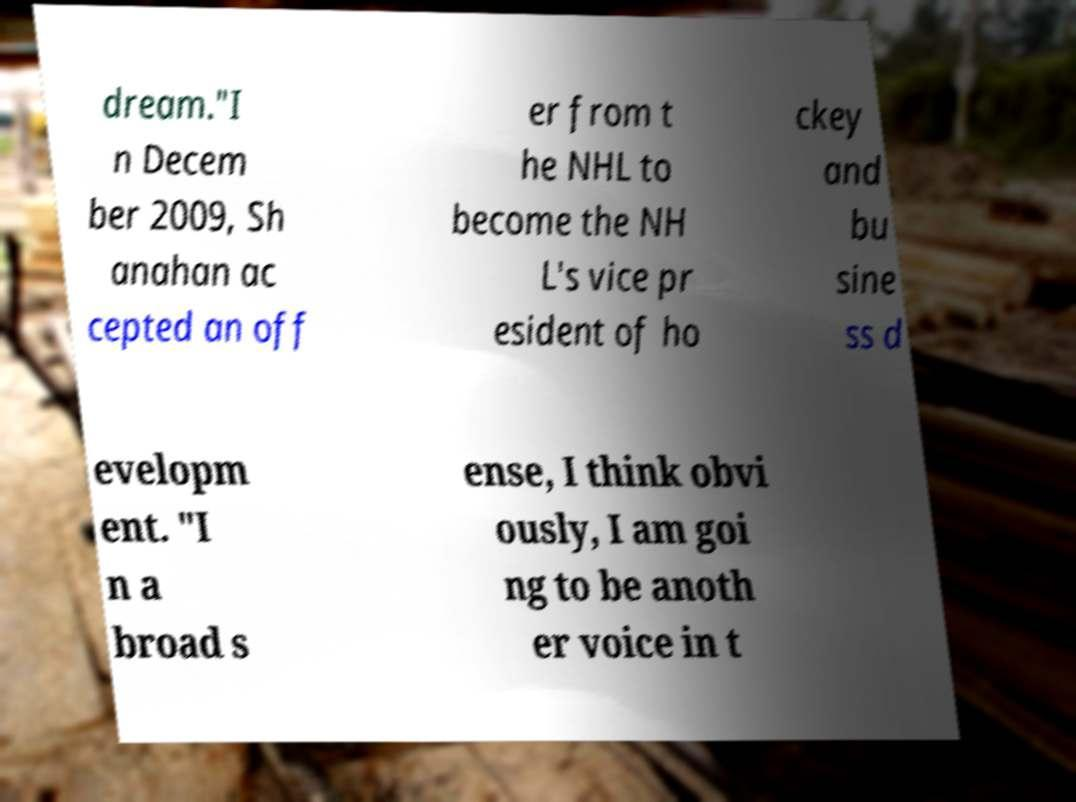Please identify and transcribe the text found in this image. dream."I n Decem ber 2009, Sh anahan ac cepted an off er from t he NHL to become the NH L's vice pr esident of ho ckey and bu sine ss d evelopm ent. "I n a broad s ense, I think obvi ously, I am goi ng to be anoth er voice in t 